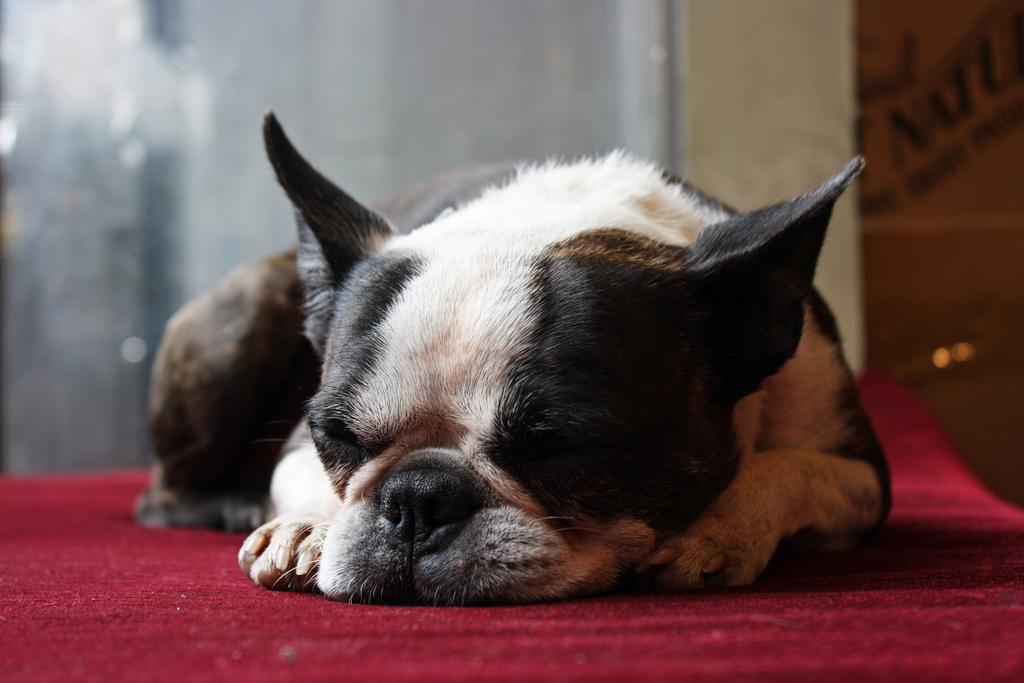What is the main subject in the center of the image? There is a dog in the center of the image. What is the dog doing in the image? The dog is sleeping. What type of flooring is visible at the bottom of the image? There is a carpet at the bottom of the image. What can be seen in the background of the image? There is a wall in the background of the image. What type of root can be seen growing from the dog's tail in the image? There is no root growing from the dog's tail in the image; the dog is simply sleeping on a carpet. 